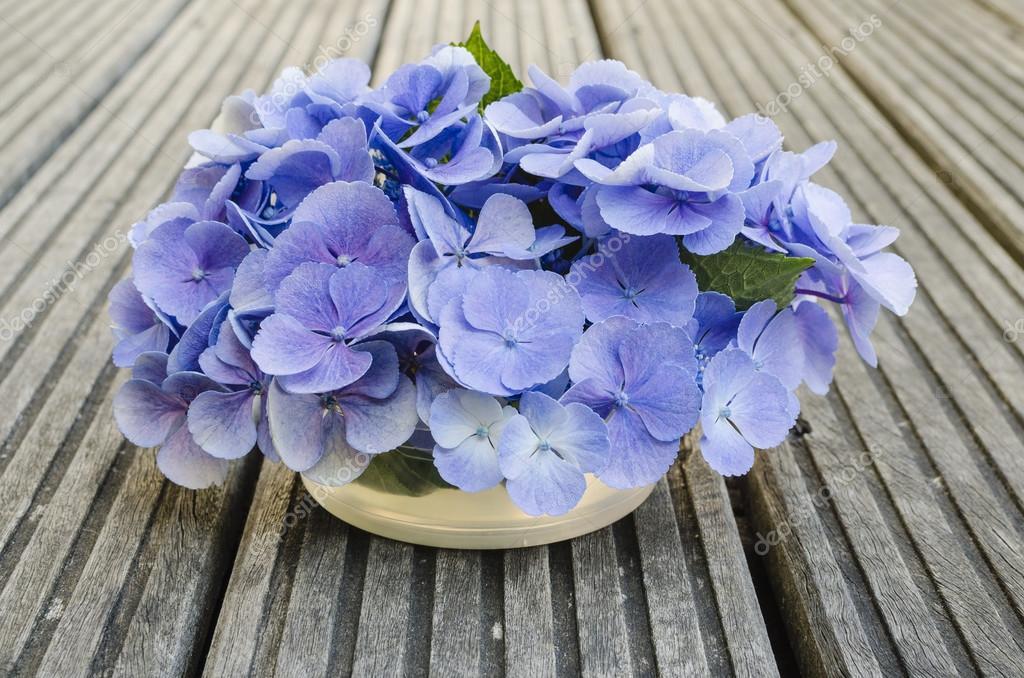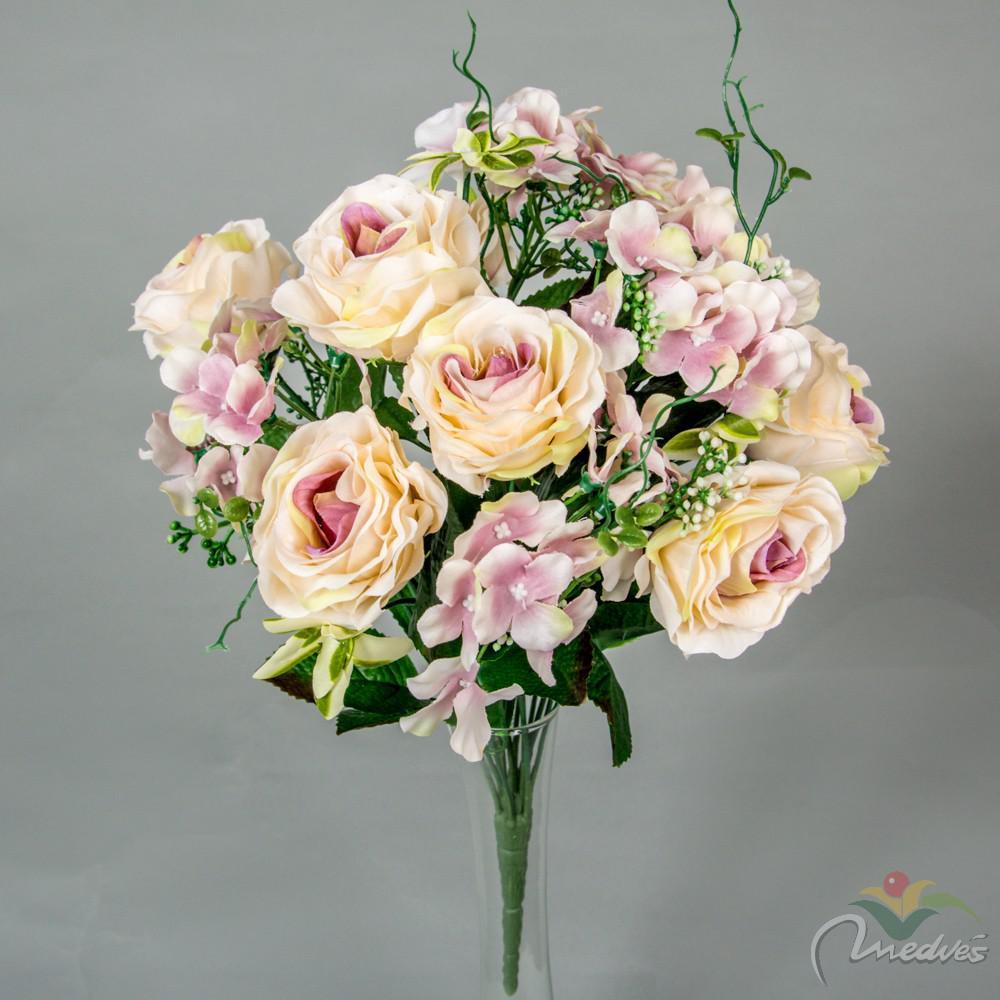The first image is the image on the left, the second image is the image on the right. Analyze the images presented: Is the assertion "The flowers in the right photo are placed in an elaborately painted vase." valid? Answer yes or no. No. The first image is the image on the left, the second image is the image on the right. For the images shown, is this caption "One of the floral arrangements has only blue flowers." true? Answer yes or no. Yes. 